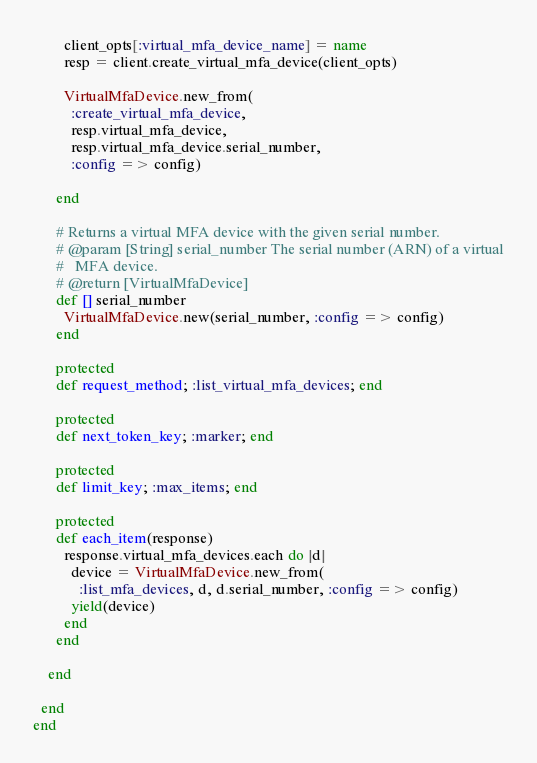Convert code to text. <code><loc_0><loc_0><loc_500><loc_500><_Ruby_>        client_opts[:virtual_mfa_device_name] = name
        resp = client.create_virtual_mfa_device(client_opts)

        VirtualMfaDevice.new_from(
          :create_virtual_mfa_device,
          resp.virtual_mfa_device,
          resp.virtual_mfa_device.serial_number,
          :config => config)

      end

      # Returns a virtual MFA device with the given serial number.
      # @param [String] serial_number The serial number (ARN) of a virtual
      #   MFA device.
      # @return [VirtualMfaDevice]
      def [] serial_number
        VirtualMfaDevice.new(serial_number, :config => config)
      end

      protected
      def request_method; :list_virtual_mfa_devices; end

      protected
      def next_token_key; :marker; end

      protected
      def limit_key; :max_items; end

      protected
      def each_item(response)
        response.virtual_mfa_devices.each do |d|
          device = VirtualMfaDevice.new_from(
            :list_mfa_devices, d, d.serial_number, :config => config)
          yield(device)
        end
      end

    end

  end
end
</code> 